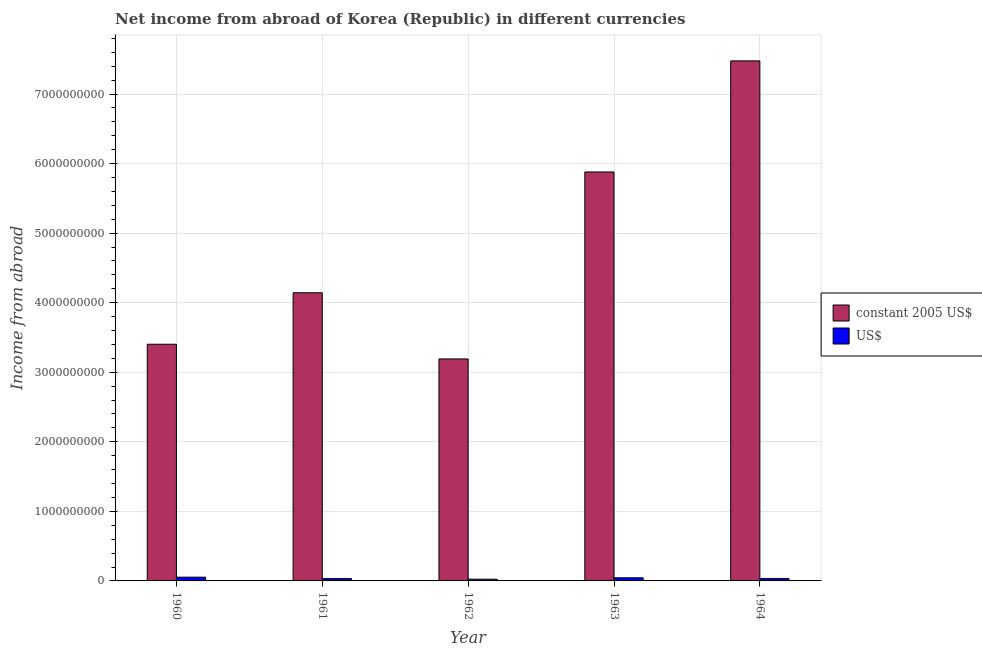How many groups of bars are there?
Offer a terse response. 5. Are the number of bars per tick equal to the number of legend labels?
Your response must be concise. Yes. What is the label of the 5th group of bars from the left?
Provide a succinct answer. 1964. In how many cases, is the number of bars for a given year not equal to the number of legend labels?
Your response must be concise. 0. What is the income from abroad in constant 2005 us$ in 1962?
Provide a short and direct response. 3.19e+09. Across all years, what is the maximum income from abroad in us$?
Keep it short and to the point. 5.39e+07. Across all years, what is the minimum income from abroad in us$?
Provide a succinct answer. 2.45e+07. In which year was the income from abroad in us$ maximum?
Offer a very short reply. 1960. What is the total income from abroad in constant 2005 us$ in the graph?
Provide a succinct answer. 2.41e+1. What is the difference between the income from abroad in constant 2005 us$ in 1962 and that in 1963?
Provide a short and direct response. -2.69e+09. What is the difference between the income from abroad in constant 2005 us$ in 1960 and the income from abroad in us$ in 1963?
Offer a very short reply. -2.48e+09. What is the average income from abroad in constant 2005 us$ per year?
Offer a very short reply. 4.82e+09. In the year 1963, what is the difference between the income from abroad in us$ and income from abroad in constant 2005 us$?
Keep it short and to the point. 0. What is the ratio of the income from abroad in us$ in 1963 to that in 1964?
Offer a very short reply. 1.29. Is the difference between the income from abroad in us$ in 1961 and 1964 greater than the difference between the income from abroad in constant 2005 us$ in 1961 and 1964?
Make the answer very short. No. What is the difference between the highest and the second highest income from abroad in constant 2005 us$?
Your answer should be very brief. 1.60e+09. What is the difference between the highest and the lowest income from abroad in constant 2005 us$?
Give a very brief answer. 4.29e+09. Is the sum of the income from abroad in constant 2005 us$ in 1962 and 1963 greater than the maximum income from abroad in us$ across all years?
Your answer should be compact. Yes. What does the 1st bar from the left in 1960 represents?
Provide a short and direct response. Constant 2005 us$. What does the 2nd bar from the right in 1964 represents?
Keep it short and to the point. Constant 2005 us$. How many bars are there?
Your response must be concise. 10. How many years are there in the graph?
Your response must be concise. 5. What is the difference between two consecutive major ticks on the Y-axis?
Your answer should be very brief. 1.00e+09. Are the values on the major ticks of Y-axis written in scientific E-notation?
Ensure brevity in your answer.  No. How many legend labels are there?
Provide a short and direct response. 2. What is the title of the graph?
Provide a short and direct response. Net income from abroad of Korea (Republic) in different currencies. What is the label or title of the Y-axis?
Provide a succinct answer. Income from abroad. What is the Income from abroad of constant 2005 US$ in 1960?
Keep it short and to the point. 3.40e+09. What is the Income from abroad in US$ in 1960?
Offer a terse response. 5.39e+07. What is the Income from abroad of constant 2005 US$ in 1961?
Offer a very short reply. 4.14e+09. What is the Income from abroad in US$ in 1961?
Your answer should be compact. 3.32e+07. What is the Income from abroad in constant 2005 US$ in 1962?
Make the answer very short. 3.19e+09. What is the Income from abroad of US$ in 1962?
Your answer should be very brief. 2.45e+07. What is the Income from abroad of constant 2005 US$ in 1963?
Give a very brief answer. 5.88e+09. What is the Income from abroad in US$ in 1963?
Give a very brief answer. 4.52e+07. What is the Income from abroad of constant 2005 US$ in 1964?
Keep it short and to the point. 7.48e+09. What is the Income from abroad of US$ in 1964?
Your answer should be compact. 3.50e+07. Across all years, what is the maximum Income from abroad in constant 2005 US$?
Ensure brevity in your answer.  7.48e+09. Across all years, what is the maximum Income from abroad in US$?
Make the answer very short. 5.39e+07. Across all years, what is the minimum Income from abroad in constant 2005 US$?
Offer a very short reply. 3.19e+09. Across all years, what is the minimum Income from abroad of US$?
Keep it short and to the point. 2.45e+07. What is the total Income from abroad in constant 2005 US$ in the graph?
Provide a succinct answer. 2.41e+1. What is the total Income from abroad in US$ in the graph?
Offer a very short reply. 1.92e+08. What is the difference between the Income from abroad of constant 2005 US$ in 1960 and that in 1961?
Give a very brief answer. -7.40e+08. What is the difference between the Income from abroad in US$ in 1960 and that in 1961?
Ensure brevity in your answer.  2.07e+07. What is the difference between the Income from abroad of constant 2005 US$ in 1960 and that in 1962?
Your response must be concise. 2.11e+08. What is the difference between the Income from abroad in US$ in 1960 and that in 1962?
Offer a very short reply. 2.94e+07. What is the difference between the Income from abroad in constant 2005 US$ in 1960 and that in 1963?
Offer a terse response. -2.48e+09. What is the difference between the Income from abroad in US$ in 1960 and that in 1963?
Offer a terse response. 8.68e+06. What is the difference between the Income from abroad of constant 2005 US$ in 1960 and that in 1964?
Your answer should be very brief. -4.07e+09. What is the difference between the Income from abroad of US$ in 1960 and that in 1964?
Make the answer very short. 1.89e+07. What is the difference between the Income from abroad of constant 2005 US$ in 1961 and that in 1962?
Your answer should be very brief. 9.52e+08. What is the difference between the Income from abroad of US$ in 1961 and that in 1962?
Your answer should be compact. 8.65e+06. What is the difference between the Income from abroad of constant 2005 US$ in 1961 and that in 1963?
Provide a succinct answer. -1.74e+09. What is the difference between the Income from abroad of US$ in 1961 and that in 1963?
Keep it short and to the point. -1.20e+07. What is the difference between the Income from abroad in constant 2005 US$ in 1961 and that in 1964?
Offer a very short reply. -3.33e+09. What is the difference between the Income from abroad in US$ in 1961 and that in 1964?
Provide a succinct answer. -1.76e+06. What is the difference between the Income from abroad of constant 2005 US$ in 1962 and that in 1963?
Your answer should be very brief. -2.69e+09. What is the difference between the Income from abroad in US$ in 1962 and that in 1963?
Provide a short and direct response. -2.07e+07. What is the difference between the Income from abroad of constant 2005 US$ in 1962 and that in 1964?
Make the answer very short. -4.29e+09. What is the difference between the Income from abroad in US$ in 1962 and that in 1964?
Your answer should be very brief. -1.04e+07. What is the difference between the Income from abroad in constant 2005 US$ in 1963 and that in 1964?
Your response must be concise. -1.60e+09. What is the difference between the Income from abroad of US$ in 1963 and that in 1964?
Make the answer very short. 1.03e+07. What is the difference between the Income from abroad in constant 2005 US$ in 1960 and the Income from abroad in US$ in 1961?
Your answer should be very brief. 3.37e+09. What is the difference between the Income from abroad of constant 2005 US$ in 1960 and the Income from abroad of US$ in 1962?
Make the answer very short. 3.38e+09. What is the difference between the Income from abroad in constant 2005 US$ in 1960 and the Income from abroad in US$ in 1963?
Give a very brief answer. 3.36e+09. What is the difference between the Income from abroad of constant 2005 US$ in 1960 and the Income from abroad of US$ in 1964?
Offer a very short reply. 3.37e+09. What is the difference between the Income from abroad in constant 2005 US$ in 1961 and the Income from abroad in US$ in 1962?
Provide a succinct answer. 4.12e+09. What is the difference between the Income from abroad in constant 2005 US$ in 1961 and the Income from abroad in US$ in 1963?
Your response must be concise. 4.10e+09. What is the difference between the Income from abroad in constant 2005 US$ in 1961 and the Income from abroad in US$ in 1964?
Make the answer very short. 4.11e+09. What is the difference between the Income from abroad in constant 2005 US$ in 1962 and the Income from abroad in US$ in 1963?
Keep it short and to the point. 3.15e+09. What is the difference between the Income from abroad of constant 2005 US$ in 1962 and the Income from abroad of US$ in 1964?
Offer a terse response. 3.16e+09. What is the difference between the Income from abroad in constant 2005 US$ in 1963 and the Income from abroad in US$ in 1964?
Offer a terse response. 5.84e+09. What is the average Income from abroad of constant 2005 US$ per year?
Give a very brief answer. 4.82e+09. What is the average Income from abroad of US$ per year?
Provide a short and direct response. 3.84e+07. In the year 1960, what is the difference between the Income from abroad of constant 2005 US$ and Income from abroad of US$?
Give a very brief answer. 3.35e+09. In the year 1961, what is the difference between the Income from abroad in constant 2005 US$ and Income from abroad in US$?
Your answer should be compact. 4.11e+09. In the year 1962, what is the difference between the Income from abroad in constant 2005 US$ and Income from abroad in US$?
Offer a terse response. 3.17e+09. In the year 1963, what is the difference between the Income from abroad in constant 2005 US$ and Income from abroad in US$?
Your answer should be very brief. 5.83e+09. In the year 1964, what is the difference between the Income from abroad of constant 2005 US$ and Income from abroad of US$?
Your answer should be compact. 7.44e+09. What is the ratio of the Income from abroad in constant 2005 US$ in 1960 to that in 1961?
Your answer should be compact. 0.82. What is the ratio of the Income from abroad of US$ in 1960 to that in 1961?
Provide a succinct answer. 1.62. What is the ratio of the Income from abroad of constant 2005 US$ in 1960 to that in 1962?
Offer a very short reply. 1.07. What is the ratio of the Income from abroad in US$ in 1960 to that in 1962?
Give a very brief answer. 2.2. What is the ratio of the Income from abroad in constant 2005 US$ in 1960 to that in 1963?
Keep it short and to the point. 0.58. What is the ratio of the Income from abroad in US$ in 1960 to that in 1963?
Make the answer very short. 1.19. What is the ratio of the Income from abroad of constant 2005 US$ in 1960 to that in 1964?
Give a very brief answer. 0.46. What is the ratio of the Income from abroad of US$ in 1960 to that in 1964?
Make the answer very short. 1.54. What is the ratio of the Income from abroad in constant 2005 US$ in 1961 to that in 1962?
Keep it short and to the point. 1.3. What is the ratio of the Income from abroad of US$ in 1961 to that in 1962?
Make the answer very short. 1.35. What is the ratio of the Income from abroad in constant 2005 US$ in 1961 to that in 1963?
Offer a very short reply. 0.7. What is the ratio of the Income from abroad in US$ in 1961 to that in 1963?
Your answer should be very brief. 0.73. What is the ratio of the Income from abroad in constant 2005 US$ in 1961 to that in 1964?
Your answer should be very brief. 0.55. What is the ratio of the Income from abroad of US$ in 1961 to that in 1964?
Your answer should be very brief. 0.95. What is the ratio of the Income from abroad in constant 2005 US$ in 1962 to that in 1963?
Keep it short and to the point. 0.54. What is the ratio of the Income from abroad of US$ in 1962 to that in 1963?
Offer a terse response. 0.54. What is the ratio of the Income from abroad in constant 2005 US$ in 1962 to that in 1964?
Give a very brief answer. 0.43. What is the ratio of the Income from abroad in US$ in 1962 to that in 1964?
Make the answer very short. 0.7. What is the ratio of the Income from abroad in constant 2005 US$ in 1963 to that in 1964?
Ensure brevity in your answer.  0.79. What is the ratio of the Income from abroad of US$ in 1963 to that in 1964?
Give a very brief answer. 1.29. What is the difference between the highest and the second highest Income from abroad in constant 2005 US$?
Your answer should be compact. 1.60e+09. What is the difference between the highest and the second highest Income from abroad in US$?
Ensure brevity in your answer.  8.68e+06. What is the difference between the highest and the lowest Income from abroad of constant 2005 US$?
Your answer should be compact. 4.29e+09. What is the difference between the highest and the lowest Income from abroad in US$?
Give a very brief answer. 2.94e+07. 